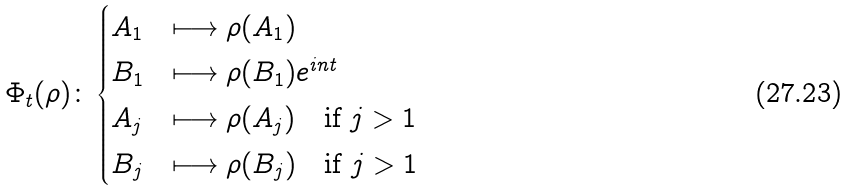Convert formula to latex. <formula><loc_0><loc_0><loc_500><loc_500>\Phi _ { t } ( \rho ) \colon \begin{cases} A _ { 1 } & \longmapsto \rho ( A _ { 1 } ) \\ B _ { 1 } & \longmapsto \rho ( B _ { 1 } ) e ^ { i n t } \\ A _ { j } & \longmapsto \rho ( A _ { j } ) \text {\quad if $j>1$} \\ B _ { j } & \longmapsto \rho ( B _ { j } ) \text {\quad if $j>1$} \end{cases}</formula> 